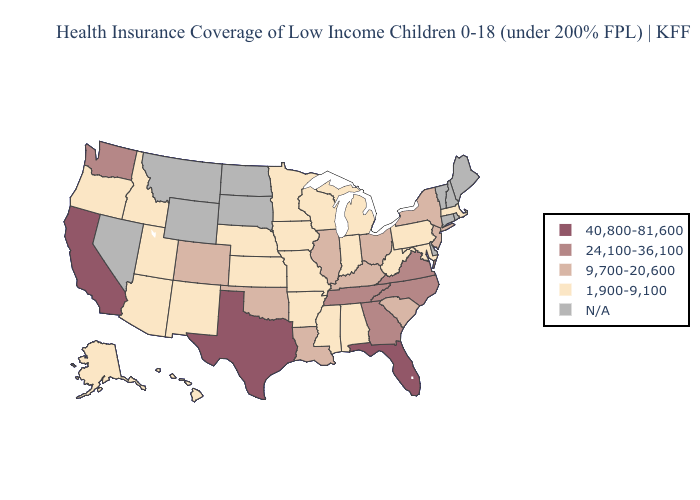Which states have the highest value in the USA?
Keep it brief. California, Florida, Texas. Does the map have missing data?
Answer briefly. Yes. Name the states that have a value in the range 24,100-36,100?
Be succinct. Georgia, North Carolina, Tennessee, Virginia, Washington. Name the states that have a value in the range N/A?
Concise answer only. Connecticut, Delaware, Maine, Montana, Nevada, New Hampshire, North Dakota, Rhode Island, South Dakota, Vermont, Wyoming. Does Massachusetts have the highest value in the Northeast?
Short answer required. No. Name the states that have a value in the range 1,900-9,100?
Keep it brief. Alabama, Alaska, Arizona, Arkansas, Hawaii, Idaho, Indiana, Iowa, Kansas, Maryland, Massachusetts, Michigan, Minnesota, Mississippi, Missouri, Nebraska, New Mexico, Oregon, Pennsylvania, Utah, West Virginia, Wisconsin. Does the map have missing data?
Write a very short answer. Yes. Name the states that have a value in the range 9,700-20,600?
Give a very brief answer. Colorado, Illinois, Kentucky, Louisiana, New Jersey, New York, Ohio, Oklahoma, South Carolina. Does the first symbol in the legend represent the smallest category?
Short answer required. No. What is the lowest value in the USA?
Keep it brief. 1,900-9,100. What is the highest value in the USA?
Concise answer only. 40,800-81,600. What is the lowest value in the USA?
Short answer required. 1,900-9,100. Name the states that have a value in the range 9,700-20,600?
Give a very brief answer. Colorado, Illinois, Kentucky, Louisiana, New Jersey, New York, Ohio, Oklahoma, South Carolina. Name the states that have a value in the range 9,700-20,600?
Give a very brief answer. Colorado, Illinois, Kentucky, Louisiana, New Jersey, New York, Ohio, Oklahoma, South Carolina. Which states have the lowest value in the West?
Answer briefly. Alaska, Arizona, Hawaii, Idaho, New Mexico, Oregon, Utah. 